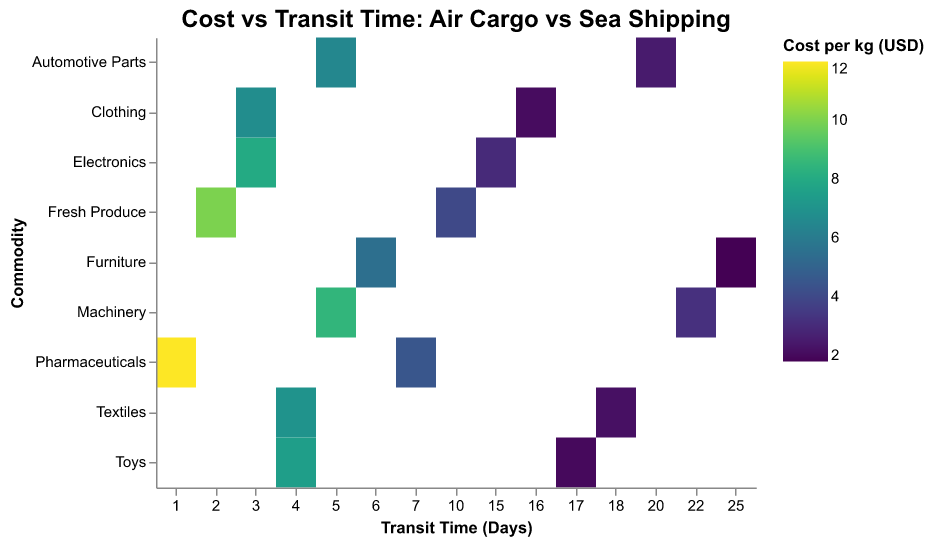What is the transit time for air shipping of Pharmaceuticals? Look at the row for Pharmaceuticals and check the Transit Time (Days) value under the Air mode.
Answer: 1 day What is the cost per kg for sea shipping of Fresh Produce? Find the Fresh Produce row and check the Cost per kg (USD) value under the Sea mode.
Answer: 4.00 USD Which commodity has the shortest transit time for air shipping? Check the rows where the Mode is Air and find the minimum Transit Time (Days) value. Pharmaceuticals has the shortest time with 1 day.
Answer: Pharmaceuticals Compare the cost per kg of air and sea shipping for Electronics. Which is more expensive? Locate the Electronics row. Compare the Cost per kg (USD) for Air (8.00 USD) and Sea (3.00 USD). 8.00 USD is more expensive.
Answer: Air is more expensive What is the difference in transit time between air and sea shipping for Toys? Locate the Toys row. Subtract the Transit Time (Days) for Air (4 days) from that of Sea (17 days).
Answer: 13 days Which commodity has the largest difference in cost per kg between air and sea shipping? Calculate the difference in Cost per kg (USD) between Air and Sea modes for each commodity. Pharmaceuticals has the largest difference: 12.00 USD - 4.50 USD = 7.50 USD.
Answer: Pharmaceuticals How many days does sea shipping for Furniture take? Find the Furniture row and check the Transit Time (Days) value under the Sea mode.
Answer: 25 days Is the cost per kg for air shipping of Textiles higher or lower than that for Machinery? Locate the Textiles and Machinery rows. Compare the Cost per kg (USD) for Air in both rows: Textiles (7.00 USD), Machinery (8.50 USD). 7.00 USD is lower.
Answer: Lower What is the average cost per kg for air shipping across all commodities? Sum the Cost per kg (USD) values for Air across all commodities and divide by the number of commodities: (8.00 + 6.50 + 10.00 + 7.00 + 12.00 + 5.50 + 7.50 + 8.50 + 6.75) / 9 = 7.97 USD.
Answer: 7.97 USD Which mode is more cost-efficient for shipping Clothing, air or sea? Look at the Clothing row and compare the Cost per kg (USD) for Air (6.75 USD) and Sea (2.10 USD). Sea is more cost-efficient.
Answer: Sea 